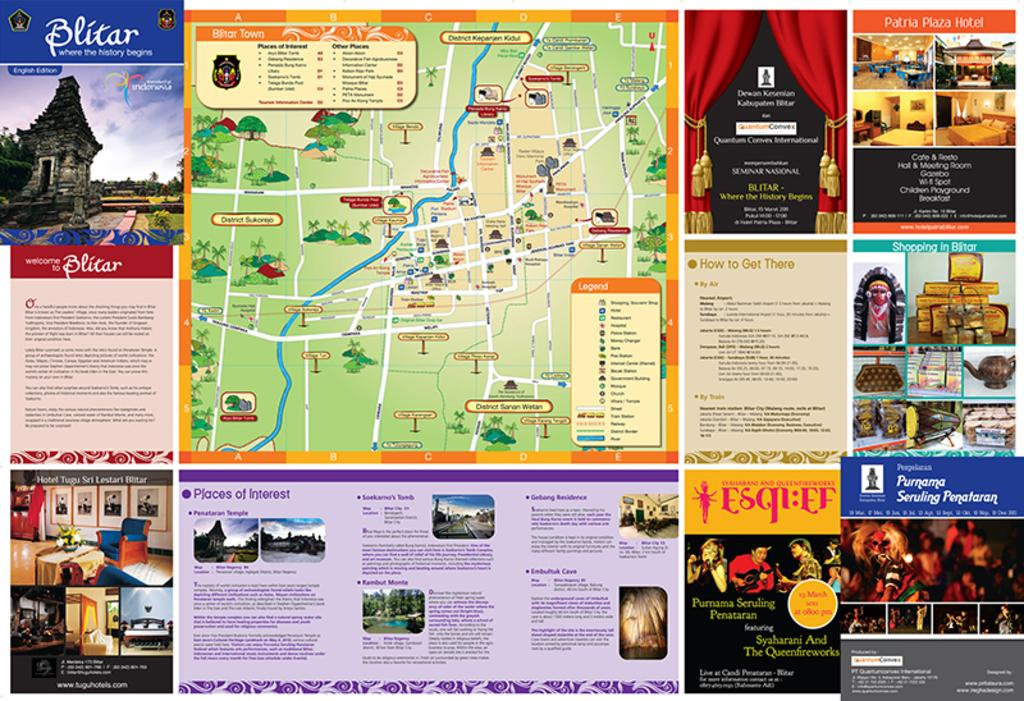<image>
Relay a brief, clear account of the picture shown. Many posters put together including one that says Purnama Seruling Penataran. 